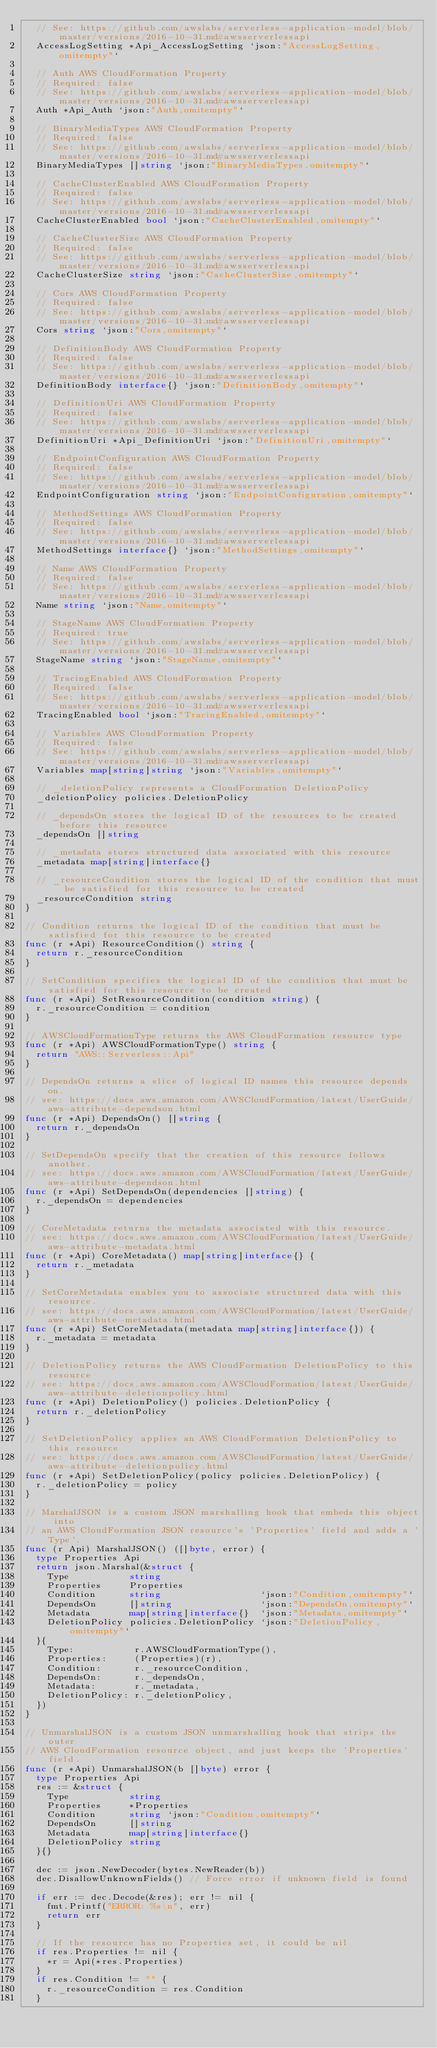<code> <loc_0><loc_0><loc_500><loc_500><_Go_>	// See: https://github.com/awslabs/serverless-application-model/blob/master/versions/2016-10-31.md#awsserverlessapi
	AccessLogSetting *Api_AccessLogSetting `json:"AccessLogSetting,omitempty"`

	// Auth AWS CloudFormation Property
	// Required: false
	// See: https://github.com/awslabs/serverless-application-model/blob/master/versions/2016-10-31.md#awsserverlessapi
	Auth *Api_Auth `json:"Auth,omitempty"`

	// BinaryMediaTypes AWS CloudFormation Property
	// Required: false
	// See: https://github.com/awslabs/serverless-application-model/blob/master/versions/2016-10-31.md#awsserverlessapi
	BinaryMediaTypes []string `json:"BinaryMediaTypes,omitempty"`

	// CacheClusterEnabled AWS CloudFormation Property
	// Required: false
	// See: https://github.com/awslabs/serverless-application-model/blob/master/versions/2016-10-31.md#awsserverlessapi
	CacheClusterEnabled bool `json:"CacheClusterEnabled,omitempty"`

	// CacheClusterSize AWS CloudFormation Property
	// Required: false
	// See: https://github.com/awslabs/serverless-application-model/blob/master/versions/2016-10-31.md#awsserverlessapi
	CacheClusterSize string `json:"CacheClusterSize,omitempty"`

	// Cors AWS CloudFormation Property
	// Required: false
	// See: https://github.com/awslabs/serverless-application-model/blob/master/versions/2016-10-31.md#awsserverlessapi
	Cors string `json:"Cors,omitempty"`

	// DefinitionBody AWS CloudFormation Property
	// Required: false
	// See: https://github.com/awslabs/serverless-application-model/blob/master/versions/2016-10-31.md#awsserverlessapi
	DefinitionBody interface{} `json:"DefinitionBody,omitempty"`

	// DefinitionUri AWS CloudFormation Property
	// Required: false
	// See: https://github.com/awslabs/serverless-application-model/blob/master/versions/2016-10-31.md#awsserverlessapi
	DefinitionUri *Api_DefinitionUri `json:"DefinitionUri,omitempty"`

	// EndpointConfiguration AWS CloudFormation Property
	// Required: false
	// See: https://github.com/awslabs/serverless-application-model/blob/master/versions/2016-10-31.md#awsserverlessapi
	EndpointConfiguration string `json:"EndpointConfiguration,omitempty"`

	// MethodSettings AWS CloudFormation Property
	// Required: false
	// See: https://github.com/awslabs/serverless-application-model/blob/master/versions/2016-10-31.md#awsserverlessapi
	MethodSettings interface{} `json:"MethodSettings,omitempty"`

	// Name AWS CloudFormation Property
	// Required: false
	// See: https://github.com/awslabs/serverless-application-model/blob/master/versions/2016-10-31.md#awsserverlessapi
	Name string `json:"Name,omitempty"`

	// StageName AWS CloudFormation Property
	// Required: true
	// See: https://github.com/awslabs/serverless-application-model/blob/master/versions/2016-10-31.md#awsserverlessapi
	StageName string `json:"StageName,omitempty"`

	// TracingEnabled AWS CloudFormation Property
	// Required: false
	// See: https://github.com/awslabs/serverless-application-model/blob/master/versions/2016-10-31.md#awsserverlessapi
	TracingEnabled bool `json:"TracingEnabled,omitempty"`

	// Variables AWS CloudFormation Property
	// Required: false
	// See: https://github.com/awslabs/serverless-application-model/blob/master/versions/2016-10-31.md#awsserverlessapi
	Variables map[string]string `json:"Variables,omitempty"`

	// _deletionPolicy represents a CloudFormation DeletionPolicy
	_deletionPolicy policies.DeletionPolicy

	// _dependsOn stores the logical ID of the resources to be created before this resource
	_dependsOn []string

	// _metadata stores structured data associated with this resource
	_metadata map[string]interface{}

	// _resourceCondition stores the logical ID of the condition that must be satisfied for this resource to be created
	_resourceCondition string
}

// Condition returns the logical ID of the condition that must be satisfied for this resource to be created
func (r *Api) ResourceCondition() string {
	return r._resourceCondition
}

// SetCondition specifies the logical ID of the condition that must be satisfied for this resource to be created
func (r *Api) SetResourceCondition(condition string) {
	r._resourceCondition = condition
}

// AWSCloudFormationType returns the AWS CloudFormation resource type
func (r *Api) AWSCloudFormationType() string {
	return "AWS::Serverless::Api"
}

// DependsOn returns a slice of logical ID names this resource depends on.
// see: https://docs.aws.amazon.com/AWSCloudFormation/latest/UserGuide/aws-attribute-dependson.html
func (r *Api) DependsOn() []string {
	return r._dependsOn
}

// SetDependsOn specify that the creation of this resource follows another.
// see: https://docs.aws.amazon.com/AWSCloudFormation/latest/UserGuide/aws-attribute-dependson.html
func (r *Api) SetDependsOn(dependencies []string) {
	r._dependsOn = dependencies
}

// CoreMetadata returns the metadata associated with this resource.
// see: https://docs.aws.amazon.com/AWSCloudFormation/latest/UserGuide/aws-attribute-metadata.html
func (r *Api) CoreMetadata() map[string]interface{} {
	return r._metadata
}

// SetCoreMetadata enables you to associate structured data with this resource.
// see: https://docs.aws.amazon.com/AWSCloudFormation/latest/UserGuide/aws-attribute-metadata.html
func (r *Api) SetCoreMetadata(metadata map[string]interface{}) {
	r._metadata = metadata
}

// DeletionPolicy returns the AWS CloudFormation DeletionPolicy to this resource
// see: https://docs.aws.amazon.com/AWSCloudFormation/latest/UserGuide/aws-attribute-deletionpolicy.html
func (r *Api) DeletionPolicy() policies.DeletionPolicy {
	return r._deletionPolicy
}

// SetDeletionPolicy applies an AWS CloudFormation DeletionPolicy to this resource
// see: https://docs.aws.amazon.com/AWSCloudFormation/latest/UserGuide/aws-attribute-deletionpolicy.html
func (r *Api) SetDeletionPolicy(policy policies.DeletionPolicy) {
	r._deletionPolicy = policy
}

// MarshalJSON is a custom JSON marshalling hook that embeds this object into
// an AWS CloudFormation JSON resource's 'Properties' field and adds a 'Type'.
func (r Api) MarshalJSON() ([]byte, error) {
	type Properties Api
	return json.Marshal(&struct {
		Type           string
		Properties     Properties
		Condition      string                  `json:"Condition,omitempty"`
		DependsOn      []string                `json:"DependsOn,omitempty"`
		Metadata       map[string]interface{}  `json:"Metadata,omitempty"`
		DeletionPolicy policies.DeletionPolicy `json:"DeletionPolicy,omitempty"`
	}{
		Type:           r.AWSCloudFormationType(),
		Properties:     (Properties)(r),
		Condition:      r._resourceCondition,
		DependsOn:      r._dependsOn,
		Metadata:       r._metadata,
		DeletionPolicy: r._deletionPolicy,
	})
}

// UnmarshalJSON is a custom JSON unmarshalling hook that strips the outer
// AWS CloudFormation resource object, and just keeps the 'Properties' field.
func (r *Api) UnmarshalJSON(b []byte) error {
	type Properties Api
	res := &struct {
		Type           string
		Properties     *Properties
		Condition      string `json:"Condition,omitempty"`
		DependsOn      []string
		Metadata       map[string]interface{}
		DeletionPolicy string
	}{}

	dec := json.NewDecoder(bytes.NewReader(b))
	dec.DisallowUnknownFields() // Force error if unknown field is found

	if err := dec.Decode(&res); err != nil {
		fmt.Printf("ERROR: %s\n", err)
		return err
	}

	// If the resource has no Properties set, it could be nil
	if res.Properties != nil {
		*r = Api(*res.Properties)
	}
	if res.Condition != "" {
		r._resourceCondition = res.Condition
	}</code> 